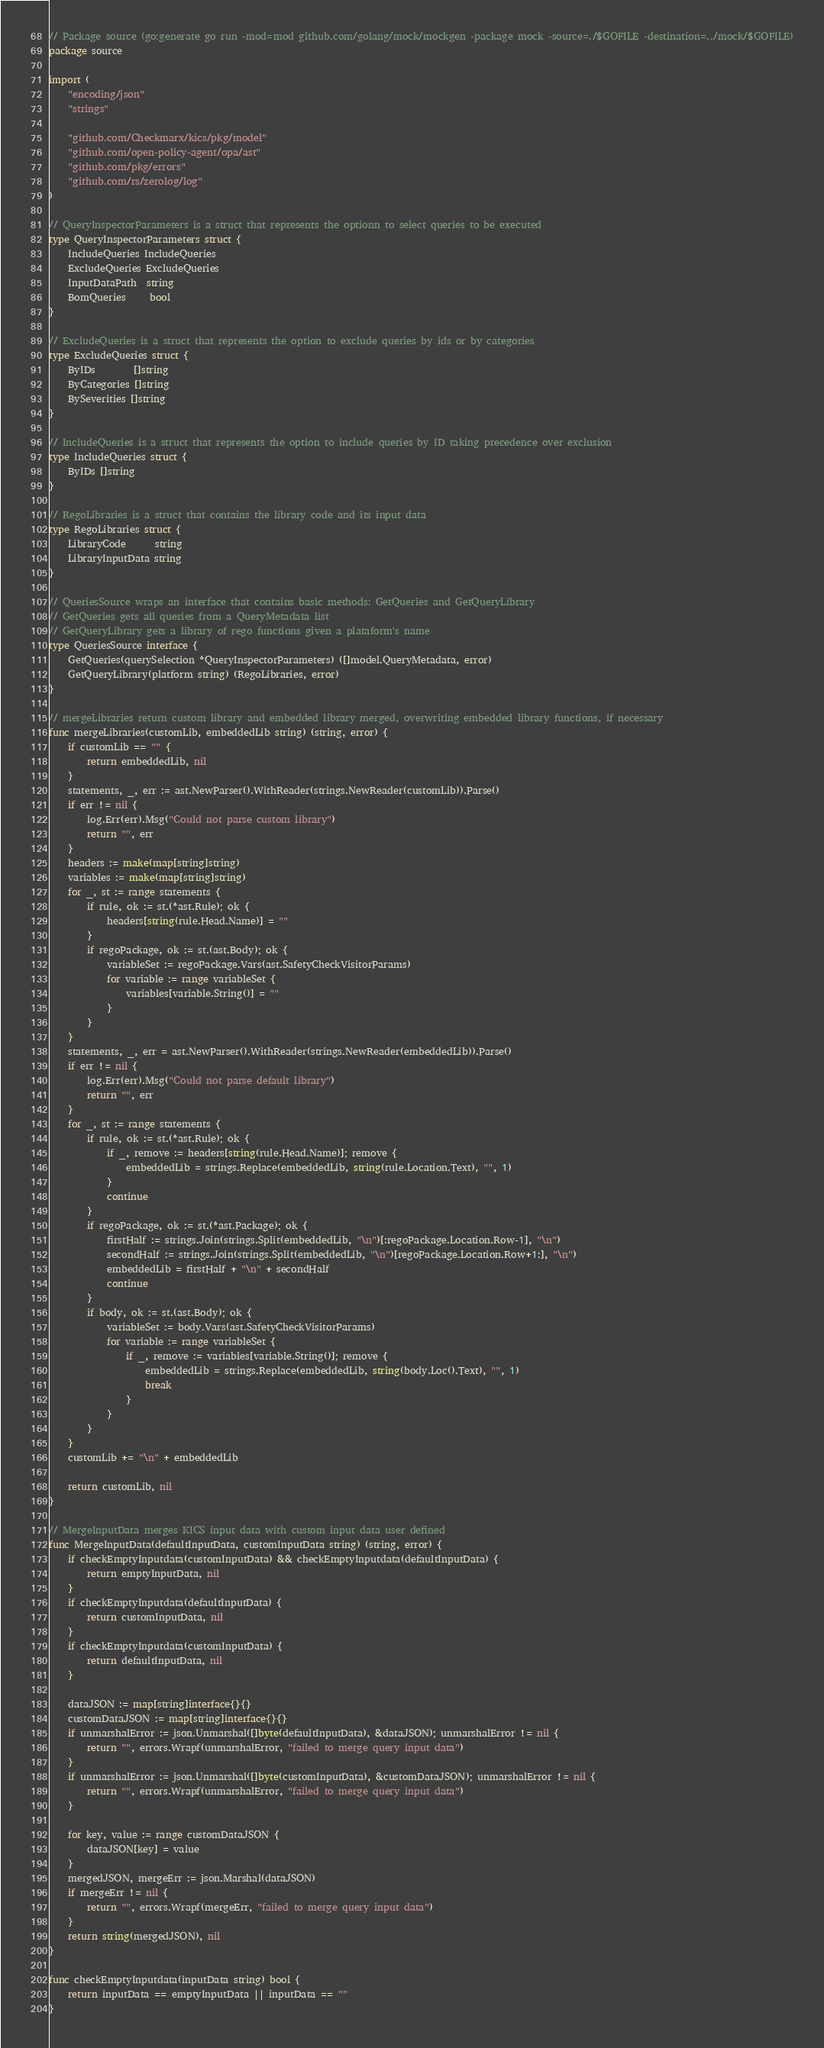Convert code to text. <code><loc_0><loc_0><loc_500><loc_500><_Go_>// Package source (go:generate go run -mod=mod github.com/golang/mock/mockgen -package mock -source=./$GOFILE -destination=../mock/$GOFILE)
package source

import (
	"encoding/json"
	"strings"

	"github.com/Checkmarx/kics/pkg/model"
	"github.com/open-policy-agent/opa/ast"
	"github.com/pkg/errors"
	"github.com/rs/zerolog/log"
)

// QueryInspectorParameters is a struct that represents the optionn to select queries to be executed
type QueryInspectorParameters struct {
	IncludeQueries IncludeQueries
	ExcludeQueries ExcludeQueries
	InputDataPath  string
	BomQueries     bool
}

// ExcludeQueries is a struct that represents the option to exclude queries by ids or by categories
type ExcludeQueries struct {
	ByIDs        []string
	ByCategories []string
	BySeverities []string
}

// IncludeQueries is a struct that represents the option to include queries by ID taking precedence over exclusion
type IncludeQueries struct {
	ByIDs []string
}

// RegoLibraries is a struct that contains the library code and its input data
type RegoLibraries struct {
	LibraryCode      string
	LibraryInputData string
}

// QueriesSource wraps an interface that contains basic methods: GetQueries and GetQueryLibrary
// GetQueries gets all queries from a QueryMetadata list
// GetQueryLibrary gets a library of rego functions given a plataform's name
type QueriesSource interface {
	GetQueries(querySelection *QueryInspectorParameters) ([]model.QueryMetadata, error)
	GetQueryLibrary(platform string) (RegoLibraries, error)
}

// mergeLibraries return custom library and embedded library merged, overwriting embedded library functions, if necessary
func mergeLibraries(customLib, embeddedLib string) (string, error) {
	if customLib == "" {
		return embeddedLib, nil
	}
	statements, _, err := ast.NewParser().WithReader(strings.NewReader(customLib)).Parse()
	if err != nil {
		log.Err(err).Msg("Could not parse custom library")
		return "", err
	}
	headers := make(map[string]string)
	variables := make(map[string]string)
	for _, st := range statements {
		if rule, ok := st.(*ast.Rule); ok {
			headers[string(rule.Head.Name)] = ""
		}
		if regoPackage, ok := st.(ast.Body); ok {
			variableSet := regoPackage.Vars(ast.SafetyCheckVisitorParams)
			for variable := range variableSet {
				variables[variable.String()] = ""
			}
		}
	}
	statements, _, err = ast.NewParser().WithReader(strings.NewReader(embeddedLib)).Parse()
	if err != nil {
		log.Err(err).Msg("Could not parse default library")
		return "", err
	}
	for _, st := range statements {
		if rule, ok := st.(*ast.Rule); ok {
			if _, remove := headers[string(rule.Head.Name)]; remove {
				embeddedLib = strings.Replace(embeddedLib, string(rule.Location.Text), "", 1)
			}
			continue
		}
		if regoPackage, ok := st.(*ast.Package); ok {
			firstHalf := strings.Join(strings.Split(embeddedLib, "\n")[:regoPackage.Location.Row-1], "\n")
			secondHalf := strings.Join(strings.Split(embeddedLib, "\n")[regoPackage.Location.Row+1:], "\n")
			embeddedLib = firstHalf + "\n" + secondHalf
			continue
		}
		if body, ok := st.(ast.Body); ok {
			variableSet := body.Vars(ast.SafetyCheckVisitorParams)
			for variable := range variableSet {
				if _, remove := variables[variable.String()]; remove {
					embeddedLib = strings.Replace(embeddedLib, string(body.Loc().Text), "", 1)
					break
				}
			}
		}
	}
	customLib += "\n" + embeddedLib

	return customLib, nil
}

// MergeInputData merges KICS input data with custom input data user defined
func MergeInputData(defaultInputData, customInputData string) (string, error) {
	if checkEmptyInputdata(customInputData) && checkEmptyInputdata(defaultInputData) {
		return emptyInputData, nil
	}
	if checkEmptyInputdata(defaultInputData) {
		return customInputData, nil
	}
	if checkEmptyInputdata(customInputData) {
		return defaultInputData, nil
	}

	dataJSON := map[string]interface{}{}
	customDataJSON := map[string]interface{}{}
	if unmarshalError := json.Unmarshal([]byte(defaultInputData), &dataJSON); unmarshalError != nil {
		return "", errors.Wrapf(unmarshalError, "failed to merge query input data")
	}
	if unmarshalError := json.Unmarshal([]byte(customInputData), &customDataJSON); unmarshalError != nil {
		return "", errors.Wrapf(unmarshalError, "failed to merge query input data")
	}

	for key, value := range customDataJSON {
		dataJSON[key] = value
	}
	mergedJSON, mergeErr := json.Marshal(dataJSON)
	if mergeErr != nil {
		return "", errors.Wrapf(mergeErr, "failed to merge query input data")
	}
	return string(mergedJSON), nil
}

func checkEmptyInputdata(inputData string) bool {
	return inputData == emptyInputData || inputData == ""
}
</code> 